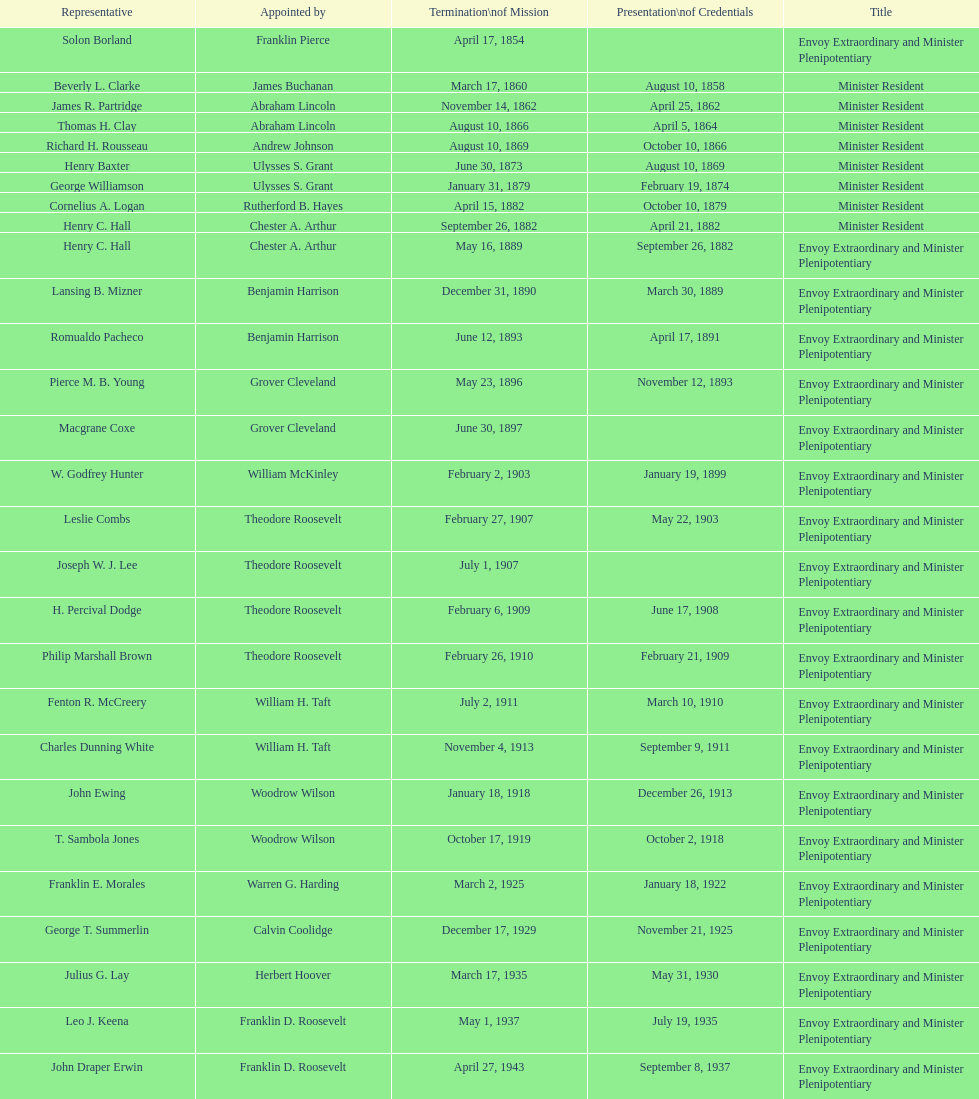Which envoy was the first appointed by woodrow wilson? John Ewing. 